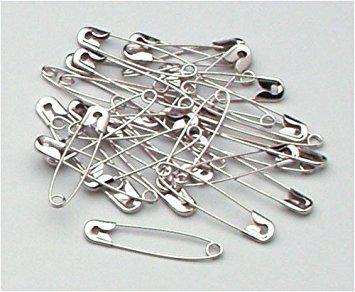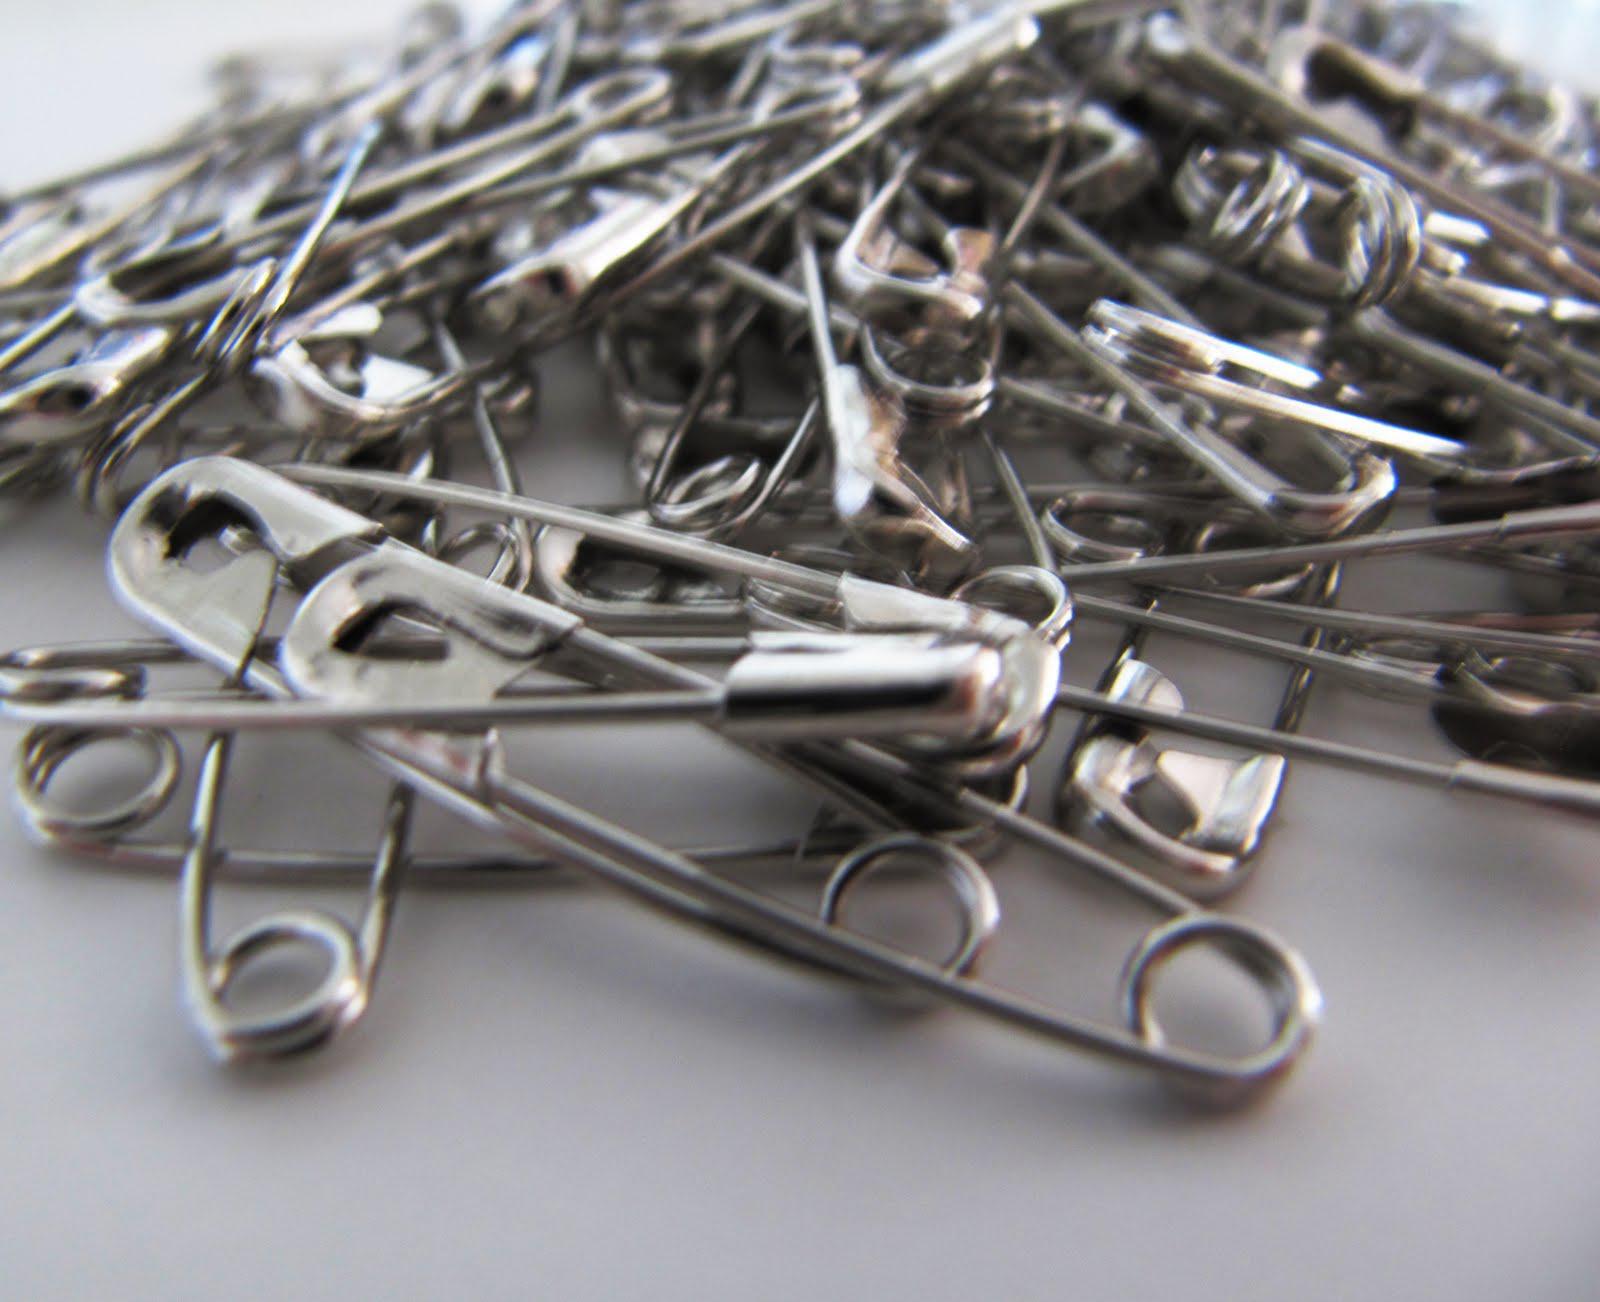The first image is the image on the left, the second image is the image on the right. For the images displayed, is the sentence "The bracelet in the image on the right uses a clasp to close." factually correct? Answer yes or no. No. The first image is the image on the left, the second image is the image on the right. Analyze the images presented: Is the assertion "All images are bracelets sitting the same position on a plain, solid colored surface." valid? Answer yes or no. No. 